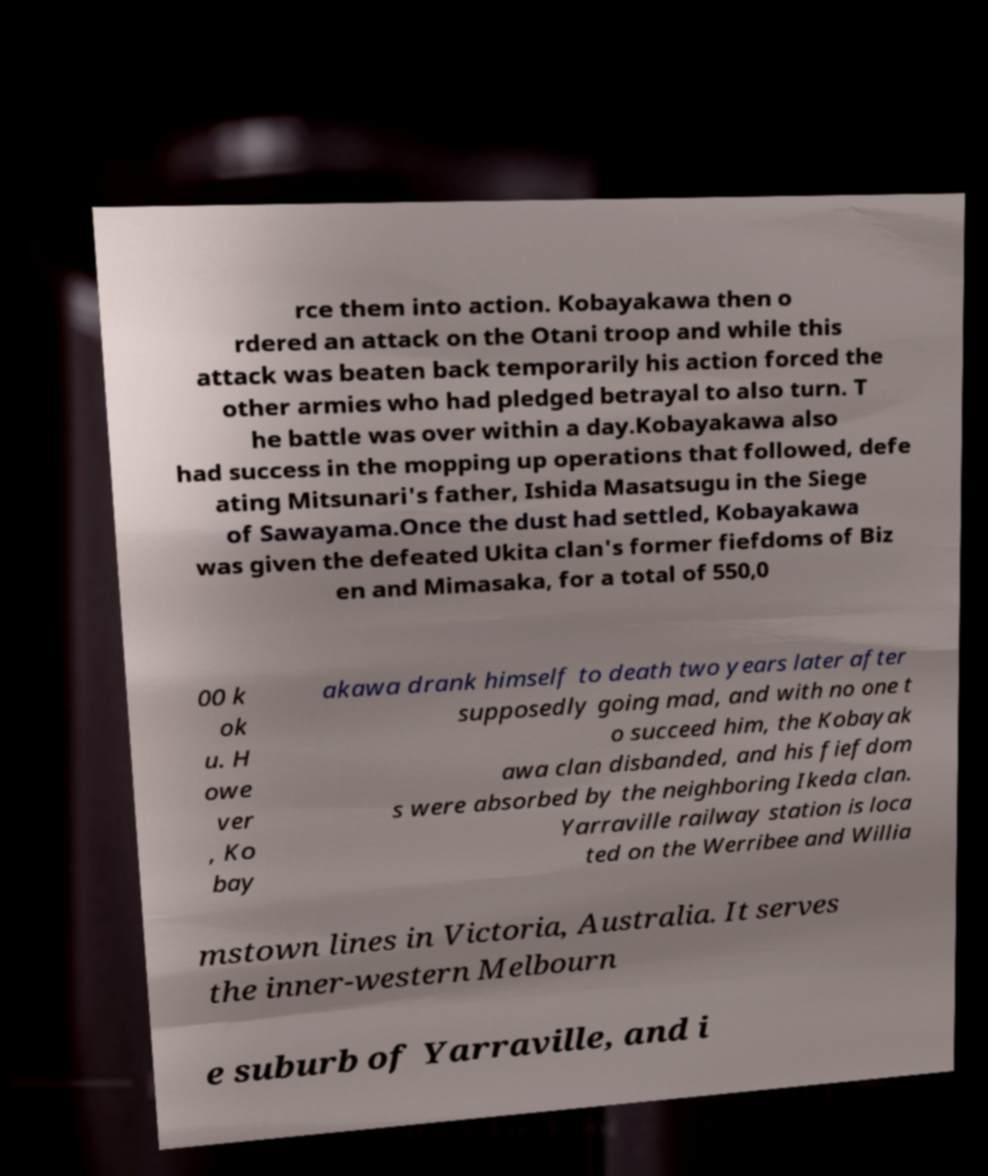What messages or text are displayed in this image? I need them in a readable, typed format. rce them into action. Kobayakawa then o rdered an attack on the Otani troop and while this attack was beaten back temporarily his action forced the other armies who had pledged betrayal to also turn. T he battle was over within a day.Kobayakawa also had success in the mopping up operations that followed, defe ating Mitsunari's father, Ishida Masatsugu in the Siege of Sawayama.Once the dust had settled, Kobayakawa was given the defeated Ukita clan's former fiefdoms of Biz en and Mimasaka, for a total of 550,0 00 k ok u. H owe ver , Ko bay akawa drank himself to death two years later after supposedly going mad, and with no one t o succeed him, the Kobayak awa clan disbanded, and his fiefdom s were absorbed by the neighboring Ikeda clan. Yarraville railway station is loca ted on the Werribee and Willia mstown lines in Victoria, Australia. It serves the inner-western Melbourn e suburb of Yarraville, and i 